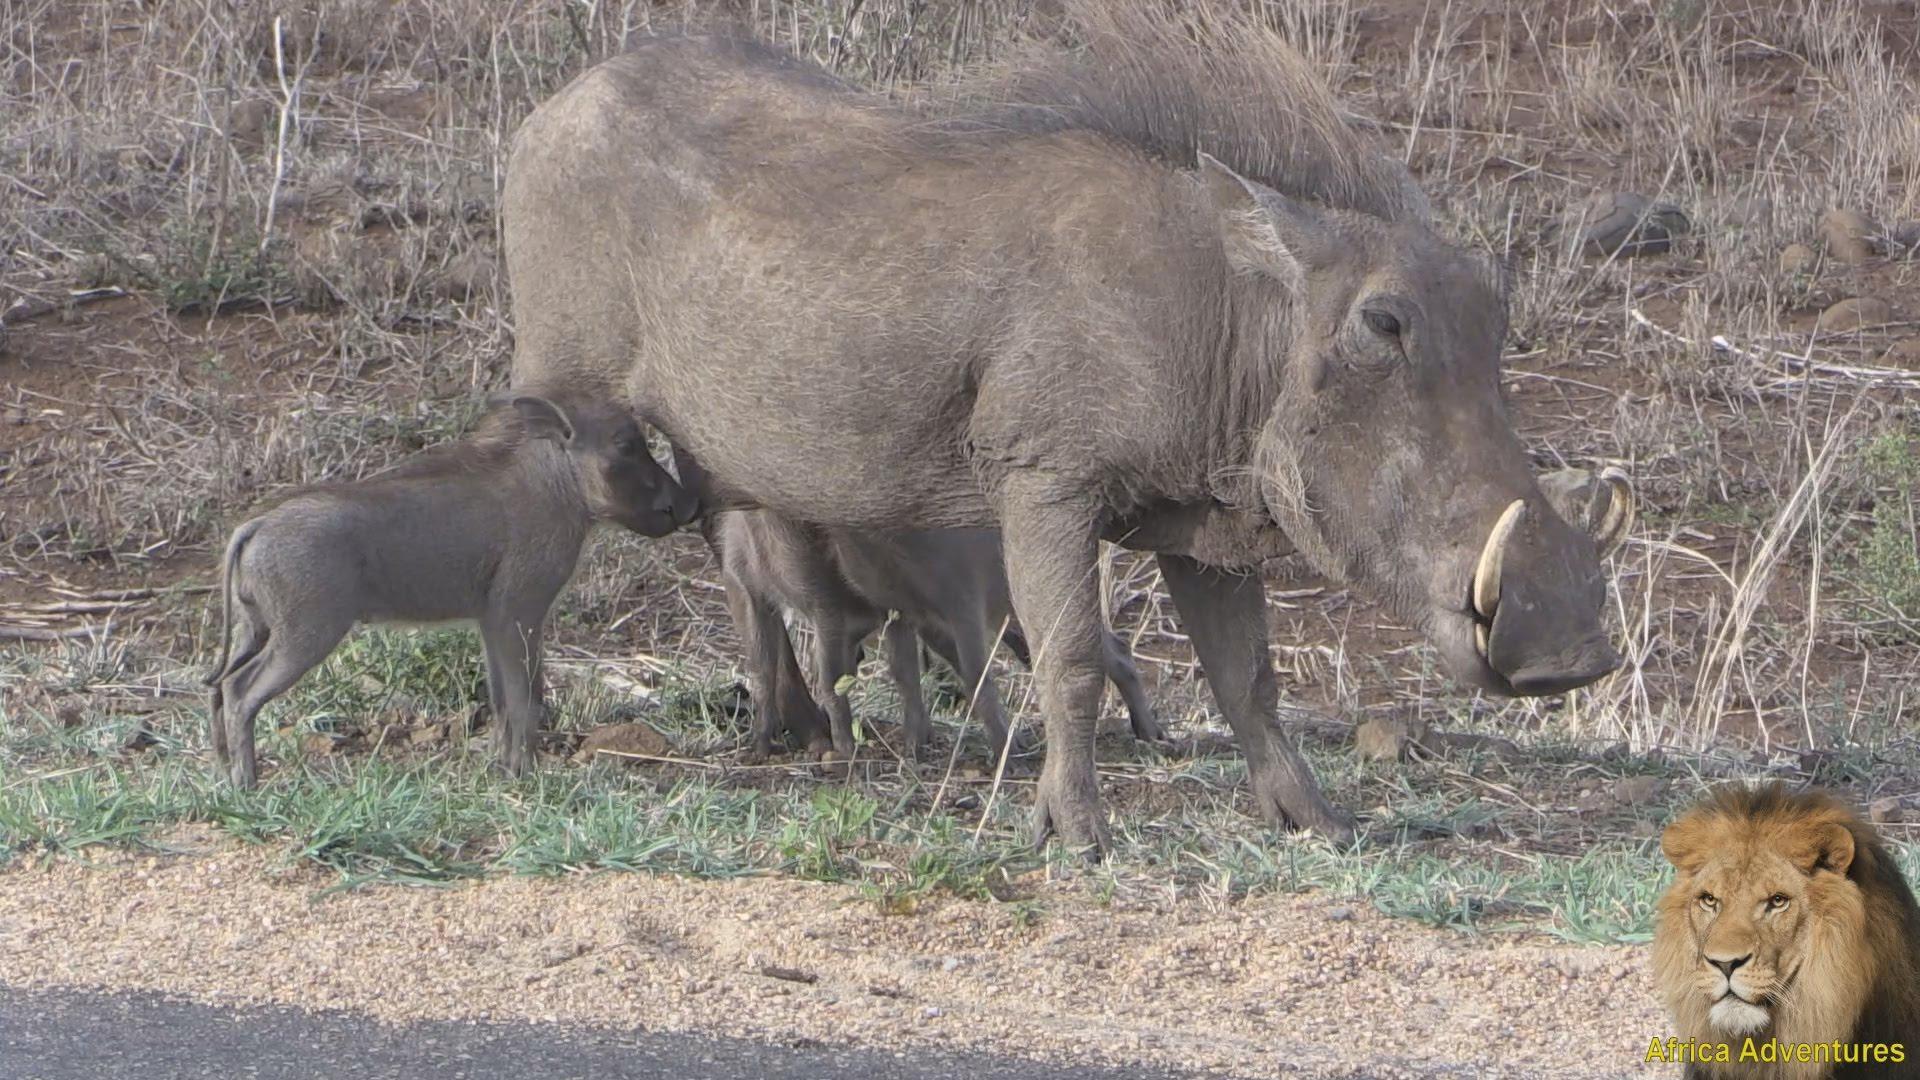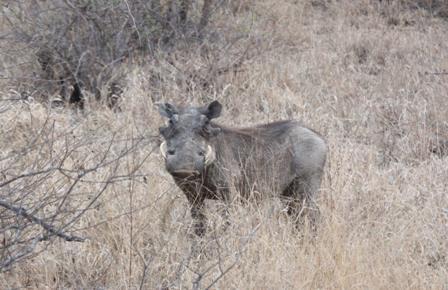The first image is the image on the left, the second image is the image on the right. Examine the images to the left and right. Is the description "One image contains more than one warthog." accurate? Answer yes or no. Yes. The first image is the image on the left, the second image is the image on the right. Given the left and right images, does the statement "We see a baby warthog in one of the images." hold true? Answer yes or no. Yes. 